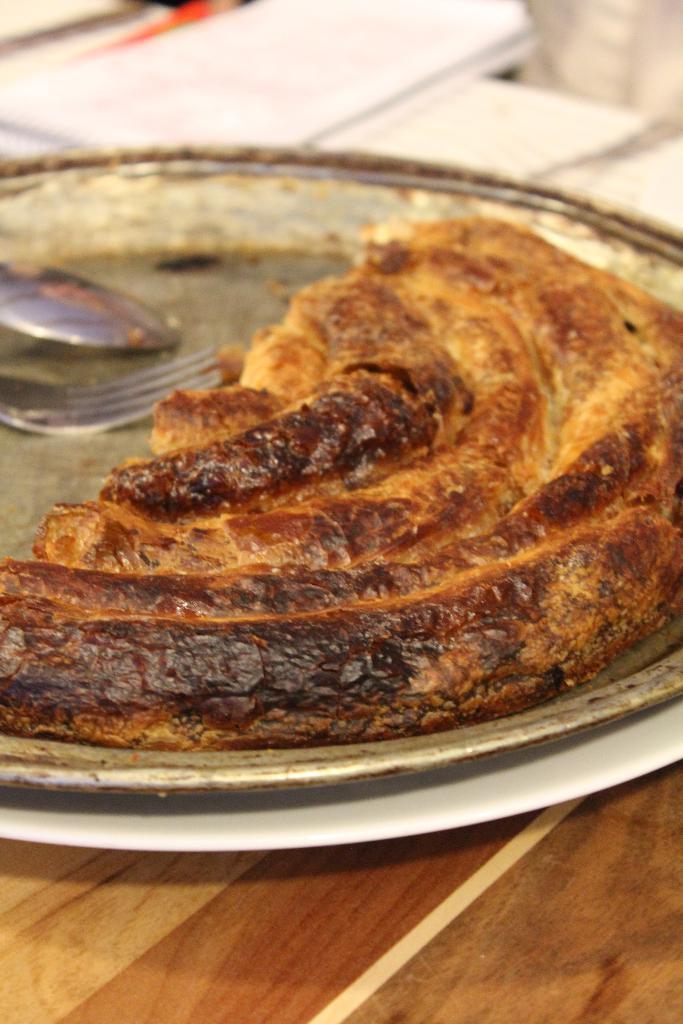Can you describe this image briefly? In the picture we can see a wooden table on it, we can see a plate with some fried food and near it, we can see a spoon and fork in the plate and beside the plate we can see some papers. 